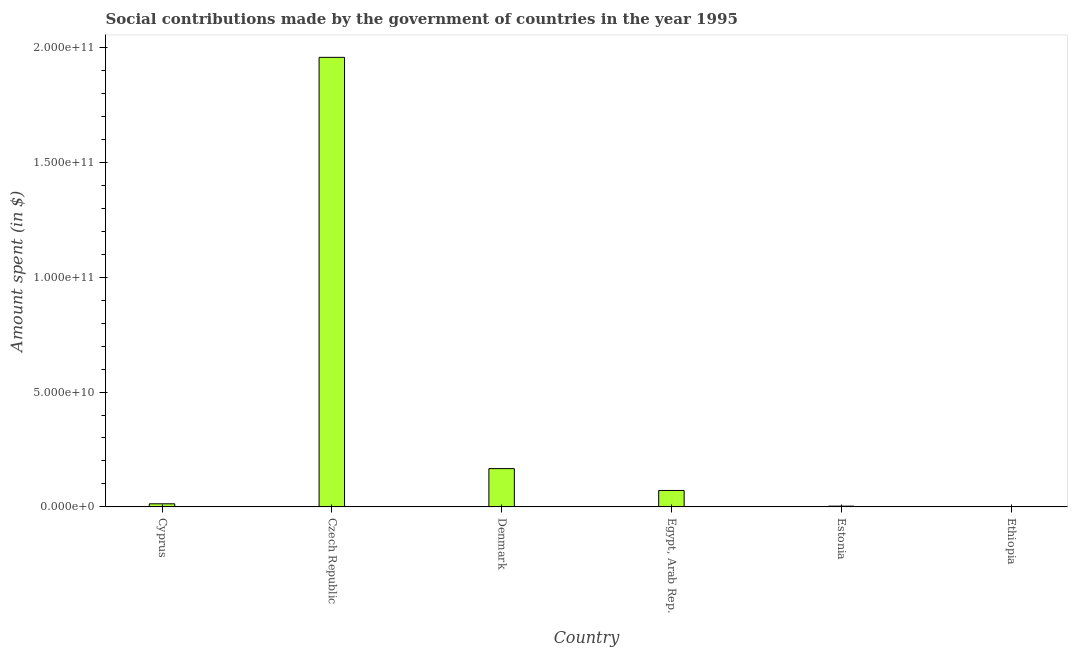Does the graph contain any zero values?
Keep it short and to the point. No. Does the graph contain grids?
Your answer should be compact. No. What is the title of the graph?
Ensure brevity in your answer.  Social contributions made by the government of countries in the year 1995. What is the label or title of the Y-axis?
Provide a short and direct response. Amount spent (in $). What is the amount spent in making social contributions in Ethiopia?
Offer a very short reply. 7.57e+07. Across all countries, what is the maximum amount spent in making social contributions?
Offer a very short reply. 1.96e+11. Across all countries, what is the minimum amount spent in making social contributions?
Give a very brief answer. 7.57e+07. In which country was the amount spent in making social contributions maximum?
Make the answer very short. Czech Republic. In which country was the amount spent in making social contributions minimum?
Your answer should be very brief. Ethiopia. What is the sum of the amount spent in making social contributions?
Your answer should be very brief. 2.21e+11. What is the difference between the amount spent in making social contributions in Cyprus and Denmark?
Provide a short and direct response. -1.53e+1. What is the average amount spent in making social contributions per country?
Your answer should be very brief. 3.69e+1. What is the median amount spent in making social contributions?
Your answer should be compact. 4.26e+09. In how many countries, is the amount spent in making social contributions greater than 90000000000 $?
Your answer should be compact. 1. What is the ratio of the amount spent in making social contributions in Cyprus to that in Czech Republic?
Your answer should be very brief. 0.01. Is the difference between the amount spent in making social contributions in Cyprus and Denmark greater than the difference between any two countries?
Offer a terse response. No. What is the difference between the highest and the second highest amount spent in making social contributions?
Offer a very short reply. 1.79e+11. What is the difference between the highest and the lowest amount spent in making social contributions?
Your response must be concise. 1.96e+11. In how many countries, is the amount spent in making social contributions greater than the average amount spent in making social contributions taken over all countries?
Keep it short and to the point. 1. How many bars are there?
Offer a terse response. 6. What is the Amount spent (in $) in Cyprus?
Offer a terse response. 1.36e+09. What is the Amount spent (in $) of Czech Republic?
Your answer should be very brief. 1.96e+11. What is the Amount spent (in $) of Denmark?
Your answer should be compact. 1.67e+1. What is the Amount spent (in $) of Egypt, Arab Rep.?
Make the answer very short. 7.16e+09. What is the Amount spent (in $) in Estonia?
Your response must be concise. 3.40e+08. What is the Amount spent (in $) of Ethiopia?
Your answer should be compact. 7.57e+07. What is the difference between the Amount spent (in $) in Cyprus and Czech Republic?
Offer a terse response. -1.94e+11. What is the difference between the Amount spent (in $) in Cyprus and Denmark?
Offer a very short reply. -1.53e+1. What is the difference between the Amount spent (in $) in Cyprus and Egypt, Arab Rep.?
Offer a terse response. -5.80e+09. What is the difference between the Amount spent (in $) in Cyprus and Estonia?
Offer a terse response. 1.02e+09. What is the difference between the Amount spent (in $) in Cyprus and Ethiopia?
Your response must be concise. 1.28e+09. What is the difference between the Amount spent (in $) in Czech Republic and Denmark?
Keep it short and to the point. 1.79e+11. What is the difference between the Amount spent (in $) in Czech Republic and Egypt, Arab Rep.?
Your response must be concise. 1.88e+11. What is the difference between the Amount spent (in $) in Czech Republic and Estonia?
Your answer should be compact. 1.95e+11. What is the difference between the Amount spent (in $) in Czech Republic and Ethiopia?
Keep it short and to the point. 1.96e+11. What is the difference between the Amount spent (in $) in Denmark and Egypt, Arab Rep.?
Offer a very short reply. 9.52e+09. What is the difference between the Amount spent (in $) in Denmark and Estonia?
Offer a very short reply. 1.63e+1. What is the difference between the Amount spent (in $) in Denmark and Ethiopia?
Give a very brief answer. 1.66e+1. What is the difference between the Amount spent (in $) in Egypt, Arab Rep. and Estonia?
Offer a very short reply. 6.82e+09. What is the difference between the Amount spent (in $) in Egypt, Arab Rep. and Ethiopia?
Your answer should be compact. 7.08e+09. What is the difference between the Amount spent (in $) in Estonia and Ethiopia?
Your answer should be compact. 2.64e+08. What is the ratio of the Amount spent (in $) in Cyprus to that in Czech Republic?
Provide a short and direct response. 0.01. What is the ratio of the Amount spent (in $) in Cyprus to that in Denmark?
Provide a short and direct response. 0.08. What is the ratio of the Amount spent (in $) in Cyprus to that in Egypt, Arab Rep.?
Keep it short and to the point. 0.19. What is the ratio of the Amount spent (in $) in Cyprus to that in Estonia?
Ensure brevity in your answer.  3.99. What is the ratio of the Amount spent (in $) in Cyprus to that in Ethiopia?
Offer a very short reply. 17.92. What is the ratio of the Amount spent (in $) in Czech Republic to that in Denmark?
Provide a succinct answer. 11.73. What is the ratio of the Amount spent (in $) in Czech Republic to that in Egypt, Arab Rep.?
Your answer should be very brief. 27.34. What is the ratio of the Amount spent (in $) in Czech Republic to that in Estonia?
Your answer should be very brief. 575.28. What is the ratio of the Amount spent (in $) in Czech Republic to that in Ethiopia?
Your answer should be very brief. 2584.57. What is the ratio of the Amount spent (in $) in Denmark to that in Egypt, Arab Rep.?
Make the answer very short. 2.33. What is the ratio of the Amount spent (in $) in Denmark to that in Estonia?
Your answer should be compact. 49.02. What is the ratio of the Amount spent (in $) in Denmark to that in Ethiopia?
Your response must be concise. 220.25. What is the ratio of the Amount spent (in $) in Egypt, Arab Rep. to that in Estonia?
Provide a succinct answer. 21.04. What is the ratio of the Amount spent (in $) in Egypt, Arab Rep. to that in Ethiopia?
Give a very brief answer. 94.54. What is the ratio of the Amount spent (in $) in Estonia to that in Ethiopia?
Ensure brevity in your answer.  4.49. 